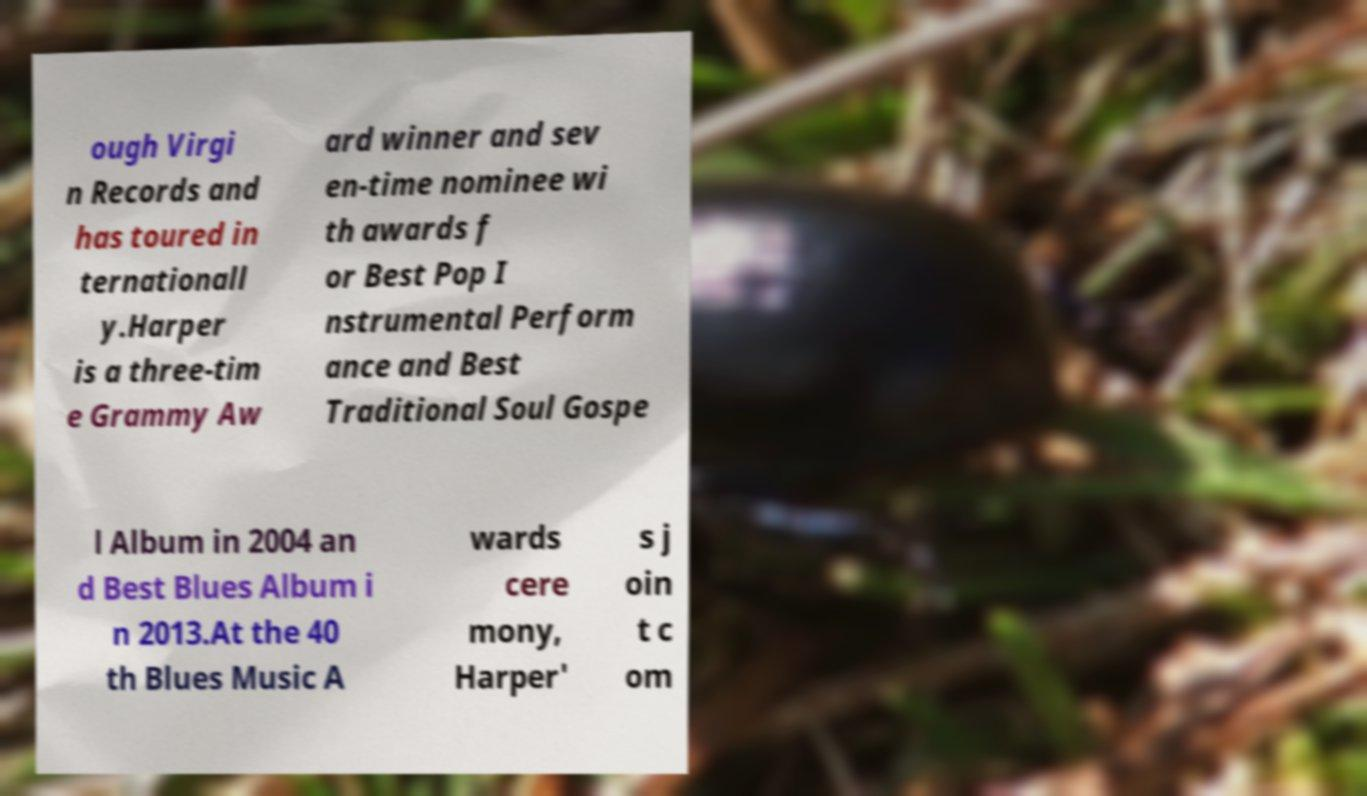I need the written content from this picture converted into text. Can you do that? ough Virgi n Records and has toured in ternationall y.Harper is a three-tim e Grammy Aw ard winner and sev en-time nominee wi th awards f or Best Pop I nstrumental Perform ance and Best Traditional Soul Gospe l Album in 2004 an d Best Blues Album i n 2013.At the 40 th Blues Music A wards cere mony, Harper' s j oin t c om 